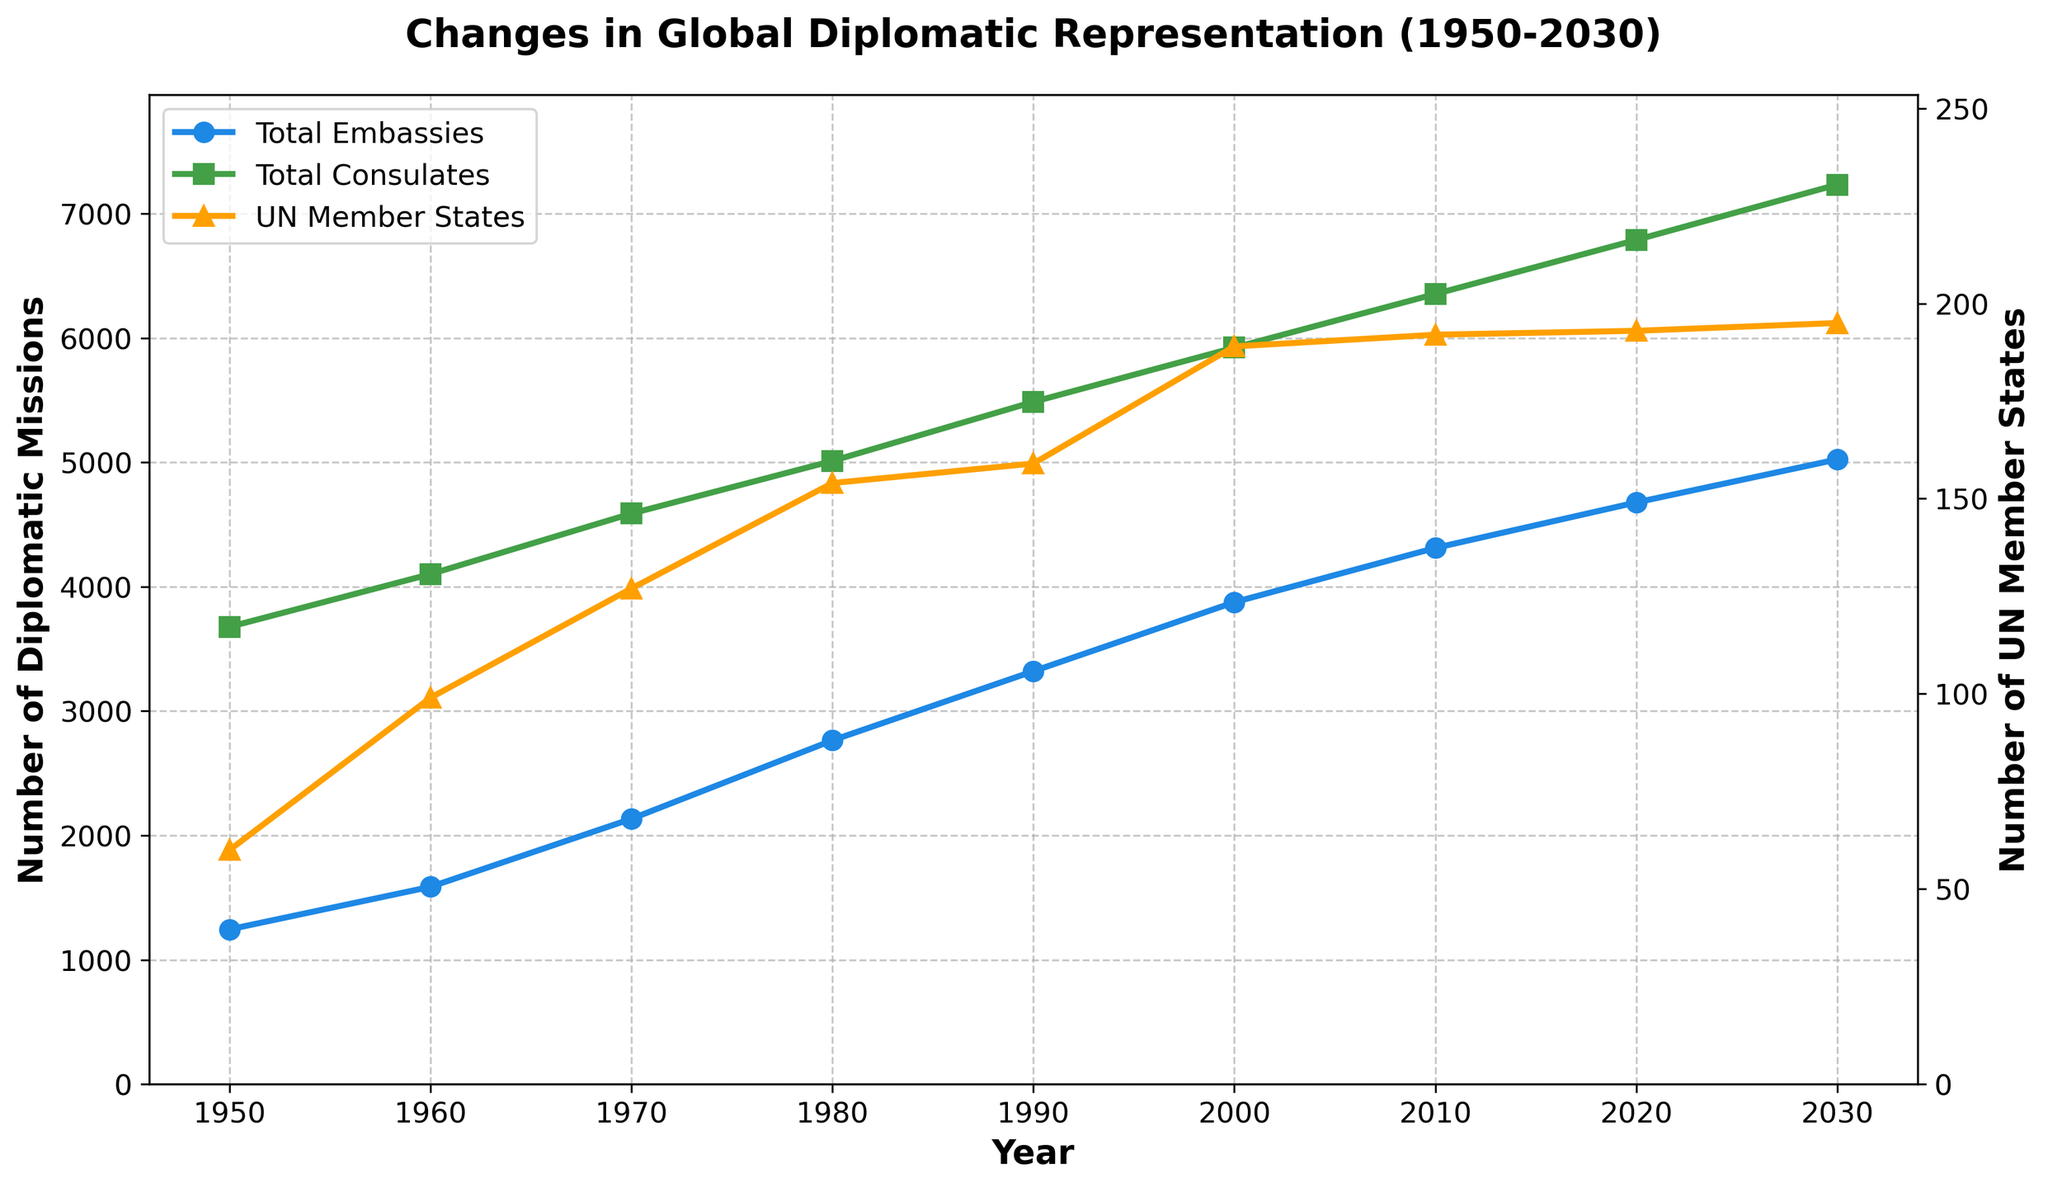What is the trend in the number of Total Embassies from 1950 to 2030? The plot shows the line representing Total Embassies increasing steadily from 1950 to 2030, indicating a continuous upward trend over these years.
Answer: Continuous increase In which decade did the number of Total Consulates first surpass 5000? From the plot, the number of Total Consulates surpasses 5000 sometime in the 1980s.
Answer: 1980s How does the growth in UN Member States from 1950 to 2020 compare with the growth in Total Embassies within the same period? The number of UN Member States increased from 60 to 193، showing a more than threefold increase. Total embassies increased from 1245 to 4678, approximately a 3.76-fold increase. Both show significant growth; however, the increase in Total Embassies is relatively larger.
Answer: UN Member States increased about 3.2 times, Total Embassies increased about 3.76 times Which year had the smallest difference between the number of Total Consulates and Total Embassies? Subtracting the number of Total Embassies from Total Consulates for each year shows the smallest difference occurs in 1950 with a difference of 2433.
Answer: 1950 What is the average rise in the number of Total Embassies per year between 1950 and 2030? The number of Total Embassies rose from 1245 in 1950 to 5024 in 2030 over 80 years. The average increase per year is (5024 - 1245) / 80 = 47.3 embassies per year.
Answer: 47.3 embassies per year Between 1970 and 1990, which category (Total Embassies or Total Consulates) showed higher absolute growth? Subtract the values of 1970 from 1990: Total Embassies increased from 2134 to 3321 (1187), and Total Consulates increased from 4589 to 5487 (898). Therefore, Total Embassies had higher absolute growth.
Answer: Total Embassies Based on the trend lines, which has a faster rate of increase since 1950, Total Embassies or Total Consulates? Both lines increase, but Total Consulates begin at a higher starting point and maintain a sharper upward slope, indicating a faster rate of increase compared to Total Embassies.
Answer: Total Consulates Approximately how many Total Diplomatic Missions per Country were there on average in 2000 and 2030? The plot uses the average metric for 2000 and 2030; the average Diplomatic Missions per Country were approximately at 51.85 in 2000 and at 62.86 in 2030 showing an increase.
Answer: 51.85 in 2000 and 62.86 in 2030 